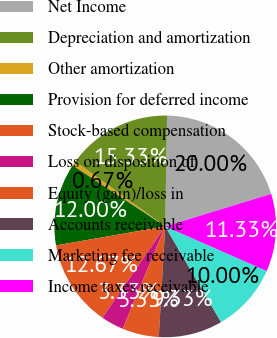<chart> <loc_0><loc_0><loc_500><loc_500><pie_chart><fcel>Net Income<fcel>Depreciation and amortization<fcel>Other amortization<fcel>Provision for deferred income<fcel>Stock-based compensation<fcel>Loss on disposition of<fcel>Equity (gain)/loss in<fcel>Accounts receivable<fcel>Marketing fee receivable<fcel>Income taxes receivable<nl><fcel>20.0%<fcel>15.33%<fcel>0.67%<fcel>12.0%<fcel>12.67%<fcel>3.33%<fcel>5.33%<fcel>9.33%<fcel>10.0%<fcel>11.33%<nl></chart> 